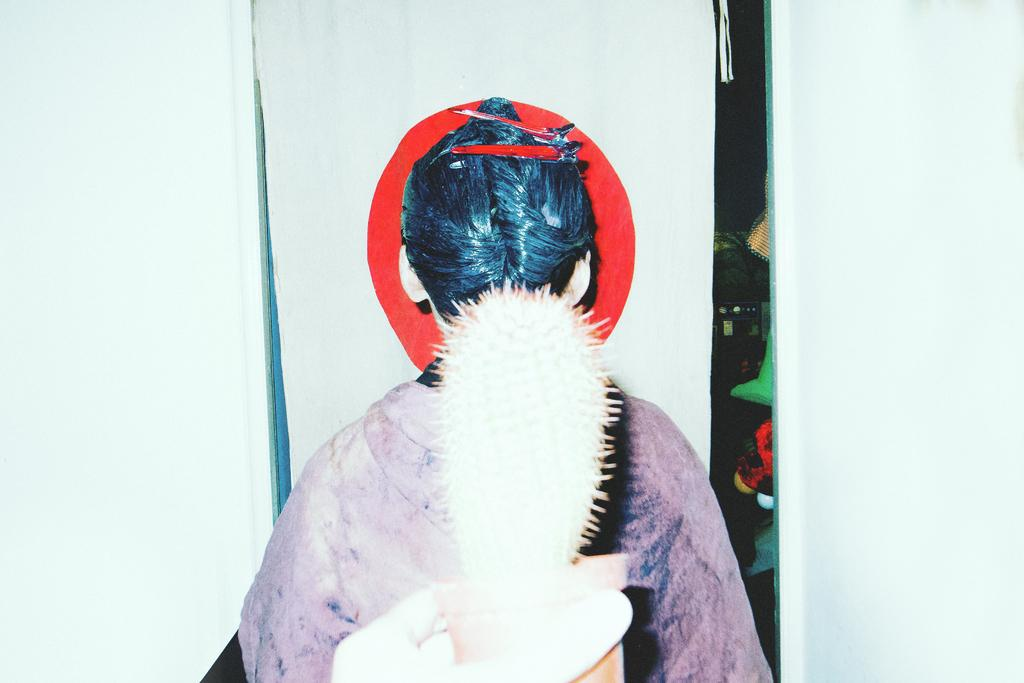What is the person on the left side of the image holding? The person on the left side of the image is holding a flower pot. What is the other person in the image doing? There is another person standing in the image. What is the color of the background in the image? The background in the image is white. What can be seen behind the people in the image? There are objects visible behind the people. What type of lace is being used to hold the flower pot in the image? There is no lace present in the image; the person is simply holding the flower pot. 